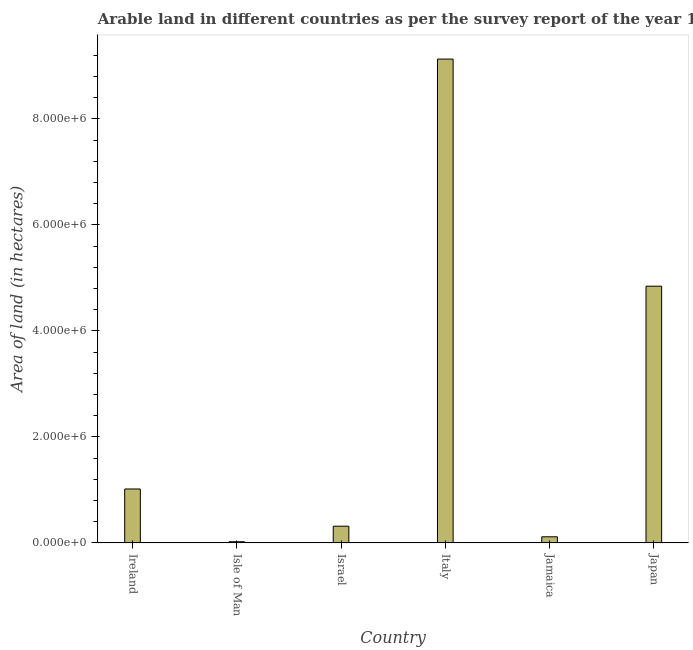Does the graph contain grids?
Make the answer very short. No. What is the title of the graph?
Provide a succinct answer. Arable land in different countries as per the survey report of the year 1983. What is the label or title of the X-axis?
Your response must be concise. Country. What is the label or title of the Y-axis?
Your answer should be very brief. Area of land (in hectares). What is the area of land in Italy?
Provide a short and direct response. 9.13e+06. Across all countries, what is the maximum area of land?
Offer a very short reply. 9.13e+06. Across all countries, what is the minimum area of land?
Provide a succinct answer. 2.15e+04. In which country was the area of land maximum?
Make the answer very short. Italy. In which country was the area of land minimum?
Ensure brevity in your answer.  Isle of Man. What is the sum of the area of land?
Make the answer very short. 1.54e+07. What is the difference between the area of land in Ireland and Japan?
Keep it short and to the point. -3.83e+06. What is the average area of land per country?
Your response must be concise. 2.57e+06. What is the median area of land?
Keep it short and to the point. 6.66e+05. What is the ratio of the area of land in Ireland to that in Jamaica?
Your response must be concise. 8.84. Is the area of land in Italy less than that in Jamaica?
Provide a succinct answer. No. Is the difference between the area of land in Isle of Man and Jamaica greater than the difference between any two countries?
Provide a succinct answer. No. What is the difference between the highest and the second highest area of land?
Give a very brief answer. 4.28e+06. Is the sum of the area of land in Israel and Jamaica greater than the maximum area of land across all countries?
Give a very brief answer. No. What is the difference between the highest and the lowest area of land?
Your answer should be compact. 9.11e+06. In how many countries, is the area of land greater than the average area of land taken over all countries?
Give a very brief answer. 2. How many bars are there?
Offer a very short reply. 6. How many countries are there in the graph?
Your answer should be very brief. 6. What is the Area of land (in hectares) of Ireland?
Your answer should be very brief. 1.02e+06. What is the Area of land (in hectares) of Isle of Man?
Your answer should be very brief. 2.15e+04. What is the Area of land (in hectares) in Israel?
Keep it short and to the point. 3.15e+05. What is the Area of land (in hectares) of Italy?
Give a very brief answer. 9.13e+06. What is the Area of land (in hectares) of Jamaica?
Make the answer very short. 1.15e+05. What is the Area of land (in hectares) of Japan?
Provide a short and direct response. 4.84e+06. What is the difference between the Area of land (in hectares) in Ireland and Isle of Man?
Your answer should be compact. 9.96e+05. What is the difference between the Area of land (in hectares) in Ireland and Israel?
Offer a terse response. 7.02e+05. What is the difference between the Area of land (in hectares) in Ireland and Italy?
Make the answer very short. -8.11e+06. What is the difference between the Area of land (in hectares) in Ireland and Jamaica?
Ensure brevity in your answer.  9.02e+05. What is the difference between the Area of land (in hectares) in Ireland and Japan?
Give a very brief answer. -3.83e+06. What is the difference between the Area of land (in hectares) in Isle of Man and Israel?
Offer a terse response. -2.94e+05. What is the difference between the Area of land (in hectares) in Isle of Man and Italy?
Keep it short and to the point. -9.11e+06. What is the difference between the Area of land (in hectares) in Isle of Man and Jamaica?
Offer a terse response. -9.35e+04. What is the difference between the Area of land (in hectares) in Isle of Man and Japan?
Offer a very short reply. -4.82e+06. What is the difference between the Area of land (in hectares) in Israel and Italy?
Offer a terse response. -8.81e+06. What is the difference between the Area of land (in hectares) in Israel and Japan?
Your answer should be very brief. -4.53e+06. What is the difference between the Area of land (in hectares) in Italy and Jamaica?
Provide a succinct answer. 9.01e+06. What is the difference between the Area of land (in hectares) in Italy and Japan?
Provide a succinct answer. 4.28e+06. What is the difference between the Area of land (in hectares) in Jamaica and Japan?
Provide a succinct answer. -4.73e+06. What is the ratio of the Area of land (in hectares) in Ireland to that in Isle of Man?
Provide a short and direct response. 47.3. What is the ratio of the Area of land (in hectares) in Ireland to that in Israel?
Your response must be concise. 3.23. What is the ratio of the Area of land (in hectares) in Ireland to that in Italy?
Offer a very short reply. 0.11. What is the ratio of the Area of land (in hectares) in Ireland to that in Jamaica?
Your response must be concise. 8.84. What is the ratio of the Area of land (in hectares) in Ireland to that in Japan?
Provide a succinct answer. 0.21. What is the ratio of the Area of land (in hectares) in Isle of Man to that in Israel?
Make the answer very short. 0.07. What is the ratio of the Area of land (in hectares) in Isle of Man to that in Italy?
Your response must be concise. 0. What is the ratio of the Area of land (in hectares) in Isle of Man to that in Jamaica?
Offer a very short reply. 0.19. What is the ratio of the Area of land (in hectares) in Isle of Man to that in Japan?
Your answer should be very brief. 0. What is the ratio of the Area of land (in hectares) in Israel to that in Italy?
Give a very brief answer. 0.04. What is the ratio of the Area of land (in hectares) in Israel to that in Jamaica?
Ensure brevity in your answer.  2.74. What is the ratio of the Area of land (in hectares) in Israel to that in Japan?
Keep it short and to the point. 0.07. What is the ratio of the Area of land (in hectares) in Italy to that in Jamaica?
Give a very brief answer. 79.37. What is the ratio of the Area of land (in hectares) in Italy to that in Japan?
Ensure brevity in your answer.  1.89. What is the ratio of the Area of land (in hectares) in Jamaica to that in Japan?
Your response must be concise. 0.02. 